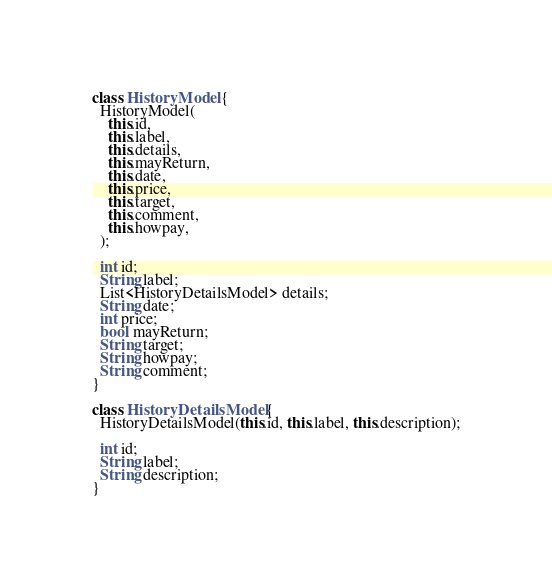<code> <loc_0><loc_0><loc_500><loc_500><_Dart_>class HistoryModel {
  HistoryModel(
    this.id,
    this.label,
    this.details,
    this.mayReturn,
    this.date,
    this.price,
    this.target,
    this.comment,
    this.howpay,
  );

  int id;
  String label;
  List<HistoryDetailsModel> details;
  String date;
  int price;
  bool mayReturn;
  String target;
  String howpay;
  String comment;
}

class HistoryDetailsModel {
  HistoryDetailsModel(this.id, this.label, this.description);

  int id;
  String label;
  String description;
}
</code> 